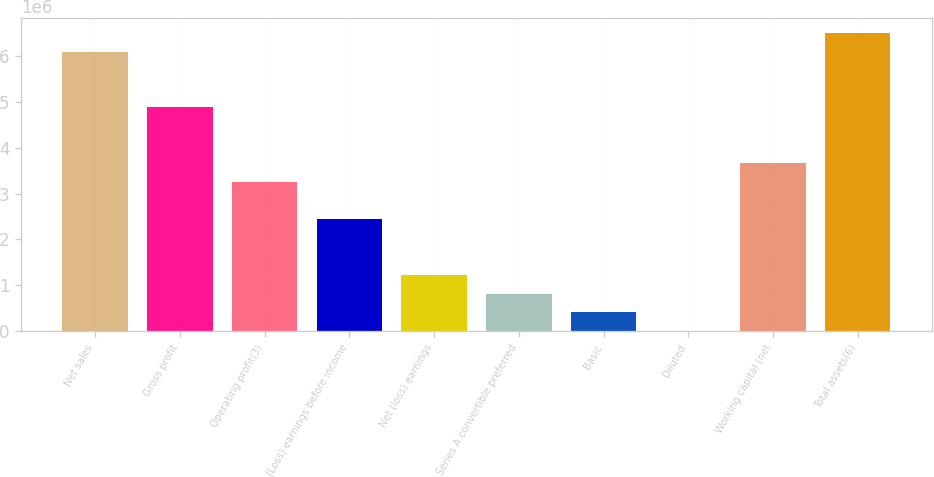<chart> <loc_0><loc_0><loc_500><loc_500><bar_chart><fcel>Net sales<fcel>Gross profit<fcel>Operating profit(3)<fcel>(Loss) earnings before income<fcel>Net (loss) earnings<fcel>Series A convertible preferred<fcel>Basic<fcel>Diluted<fcel>Working capital (net<fcel>Total assets(6)<nl><fcel>6.10047e+06<fcel>4.88038e+06<fcel>3.25359e+06<fcel>2.44019e+06<fcel>1.22009e+06<fcel>813396<fcel>406698<fcel>0.02<fcel>3.66028e+06<fcel>6.50717e+06<nl></chart> 